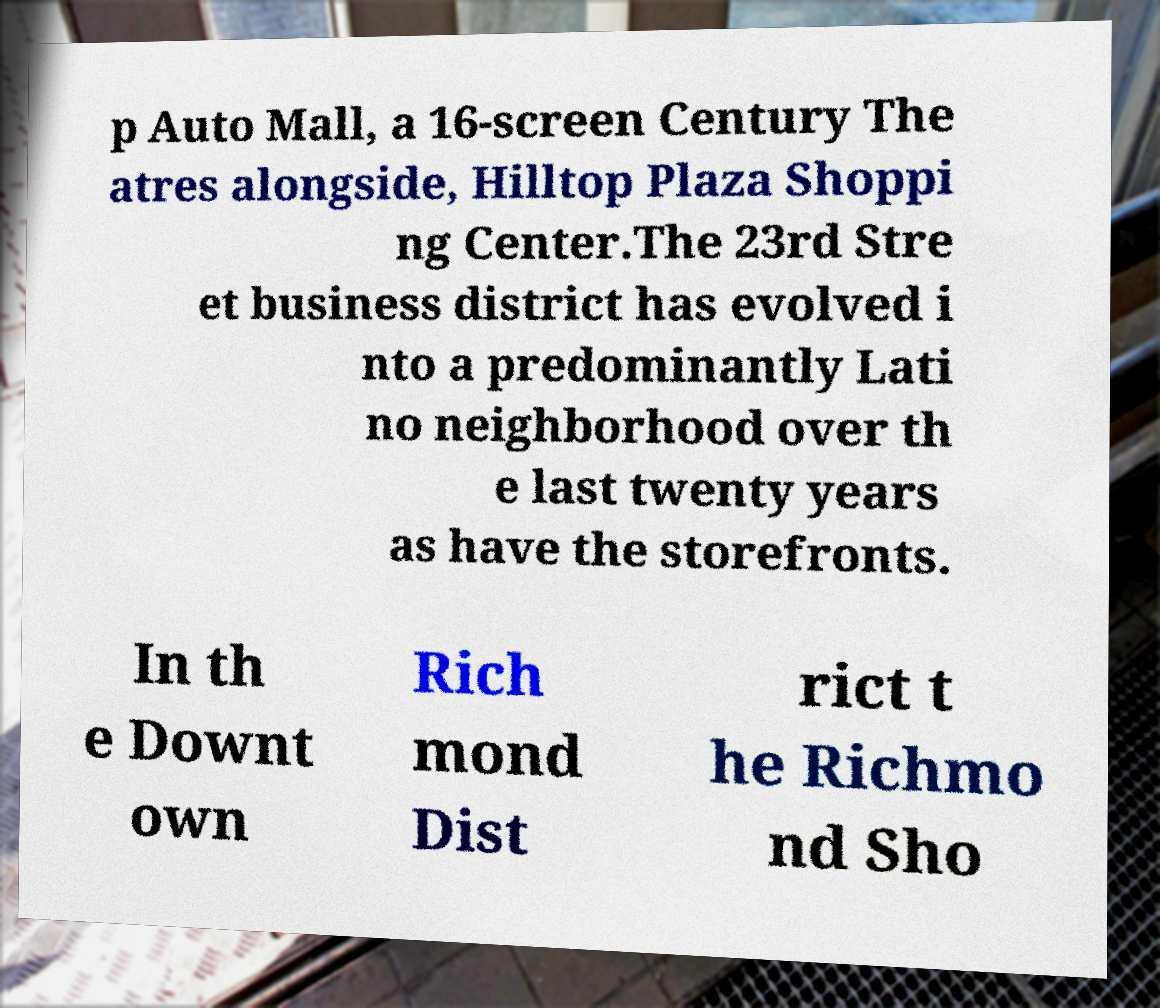Please identify and transcribe the text found in this image. p Auto Mall, a 16-screen Century The atres alongside, Hilltop Plaza Shoppi ng Center.The 23rd Stre et business district has evolved i nto a predominantly Lati no neighborhood over th e last twenty years as have the storefronts. In th e Downt own Rich mond Dist rict t he Richmo nd Sho 